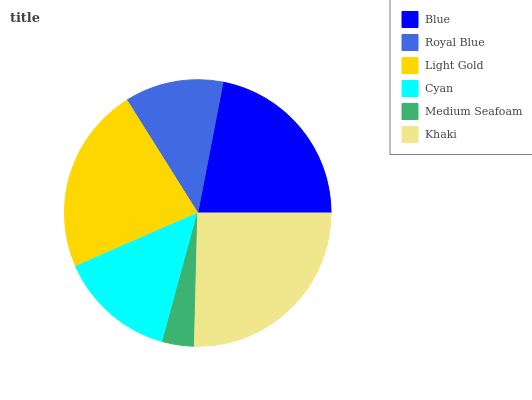Is Medium Seafoam the minimum?
Answer yes or no. Yes. Is Khaki the maximum?
Answer yes or no. Yes. Is Royal Blue the minimum?
Answer yes or no. No. Is Royal Blue the maximum?
Answer yes or no. No. Is Blue greater than Royal Blue?
Answer yes or no. Yes. Is Royal Blue less than Blue?
Answer yes or no. Yes. Is Royal Blue greater than Blue?
Answer yes or no. No. Is Blue less than Royal Blue?
Answer yes or no. No. Is Blue the high median?
Answer yes or no. Yes. Is Cyan the low median?
Answer yes or no. Yes. Is Medium Seafoam the high median?
Answer yes or no. No. Is Royal Blue the low median?
Answer yes or no. No. 